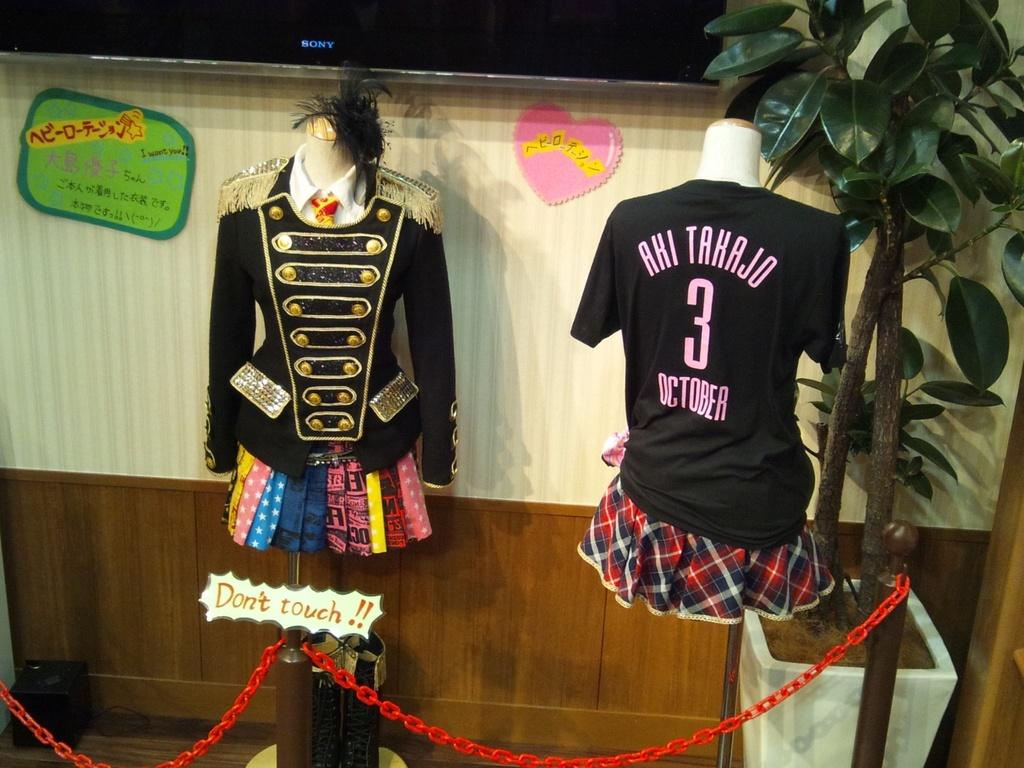<image>
Write a terse but informative summary of the picture. The sign infront of the outfits on display warns others not to touch. 